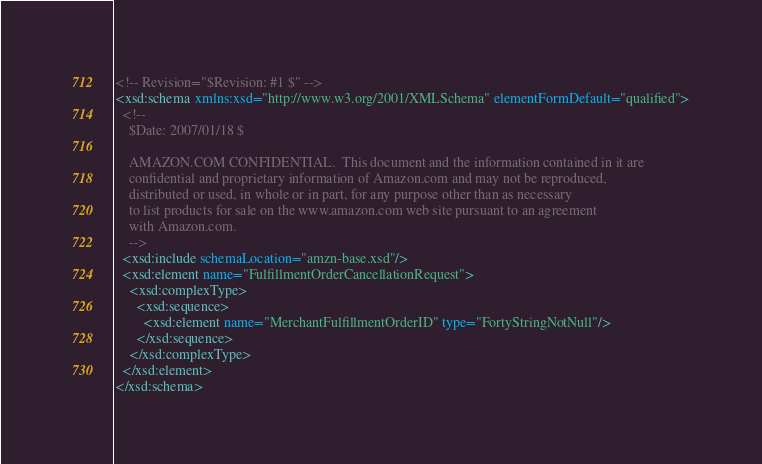<code> <loc_0><loc_0><loc_500><loc_500><_XML_><!-- Revision="$Revision: #1 $" -->
<xsd:schema xmlns:xsd="http://www.w3.org/2001/XMLSchema" elementFormDefault="qualified">
  <!--
    $Date: 2007/01/18 $
 
    AMAZON.COM CONFIDENTIAL.  This document and the information contained in it are
    confidential and proprietary information of Amazon.com and may not be reproduced, 
    distributed or used, in whole or in part, for any purpose other than as necessary 
    to list products for sale on the www.amazon.com web site pursuant to an agreement 
    with Amazon.com.
    -->
  <xsd:include schemaLocation="amzn-base.xsd"/>
  <xsd:element name="FulfillmentOrderCancellationRequest">
    <xsd:complexType>
      <xsd:sequence>
        <xsd:element name="MerchantFulfillmentOrderID" type="FortyStringNotNull"/>
      </xsd:sequence>
    </xsd:complexType>
  </xsd:element>
</xsd:schema>


</code> 